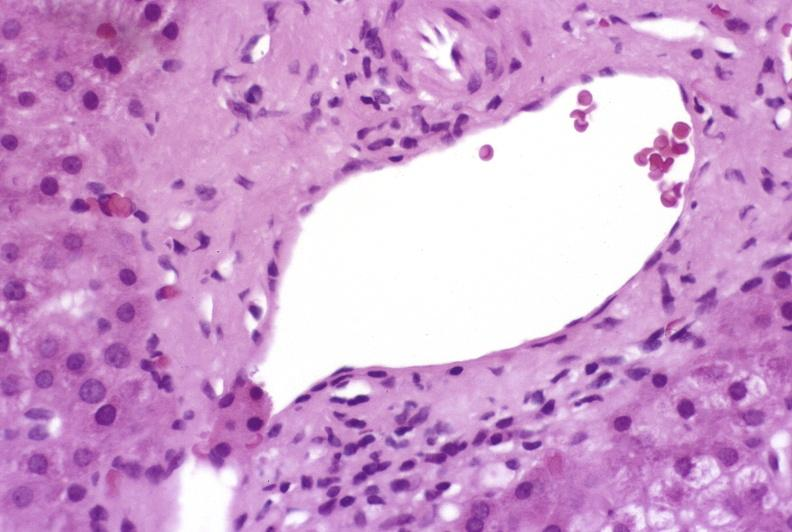what is present?
Answer the question using a single word or phrase. Liver 